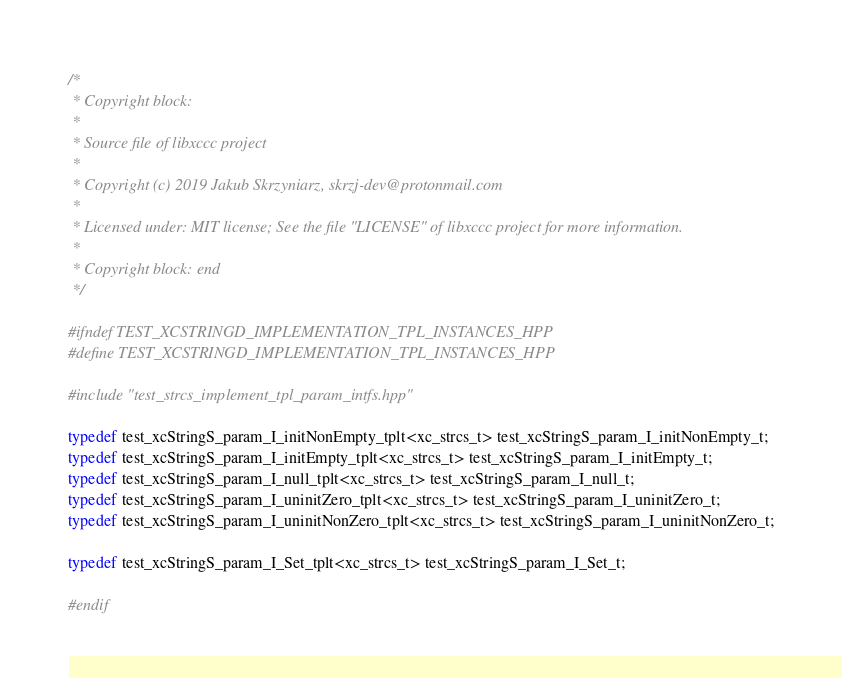<code> <loc_0><loc_0><loc_500><loc_500><_C++_>/*
 * Copyright block:
 *
 * Source file of libxccc project
 *
 * Copyright (c) 2019 Jakub Skrzyniarz, skrzj-dev@protonmail.com
 *
 * Licensed under: MIT license; See the file "LICENSE" of libxccc project for more information.
 *
 * Copyright block: end
 */

#ifndef TEST_XCSTRINGD_IMPLEMENTATION_TPL_INSTANCES_HPP
#define TEST_XCSTRINGD_IMPLEMENTATION_TPL_INSTANCES_HPP

#include "test_strcs_implement_tpl_param_intfs.hpp"

typedef test_xcStringS_param_I_initNonEmpty_tplt<xc_strcs_t> test_xcStringS_param_I_initNonEmpty_t;
typedef test_xcStringS_param_I_initEmpty_tplt<xc_strcs_t> test_xcStringS_param_I_initEmpty_t;
typedef test_xcStringS_param_I_null_tplt<xc_strcs_t> test_xcStringS_param_I_null_t;
typedef test_xcStringS_param_I_uninitZero_tplt<xc_strcs_t> test_xcStringS_param_I_uninitZero_t;
typedef test_xcStringS_param_I_uninitNonZero_tplt<xc_strcs_t> test_xcStringS_param_I_uninitNonZero_t;

typedef test_xcStringS_param_I_Set_tplt<xc_strcs_t> test_xcStringS_param_I_Set_t;

#endif
</code> 